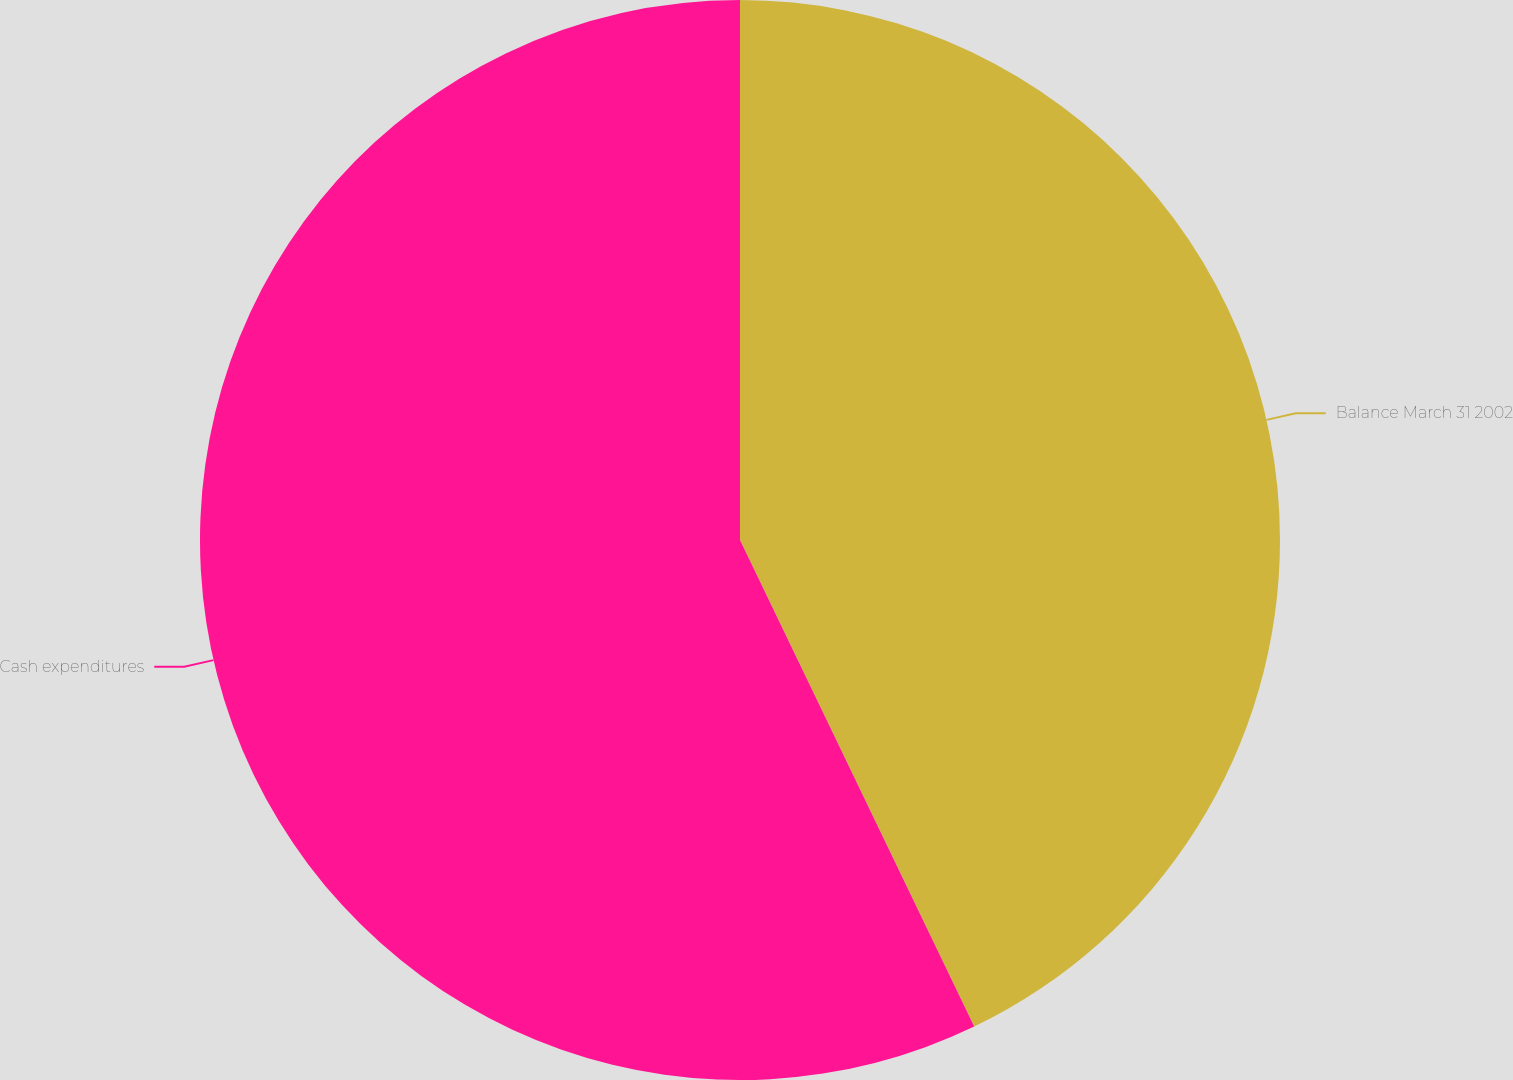Convert chart. <chart><loc_0><loc_0><loc_500><loc_500><pie_chart><fcel>Balance March 31 2002<fcel>Cash expenditures<nl><fcel>42.86%<fcel>57.14%<nl></chart> 